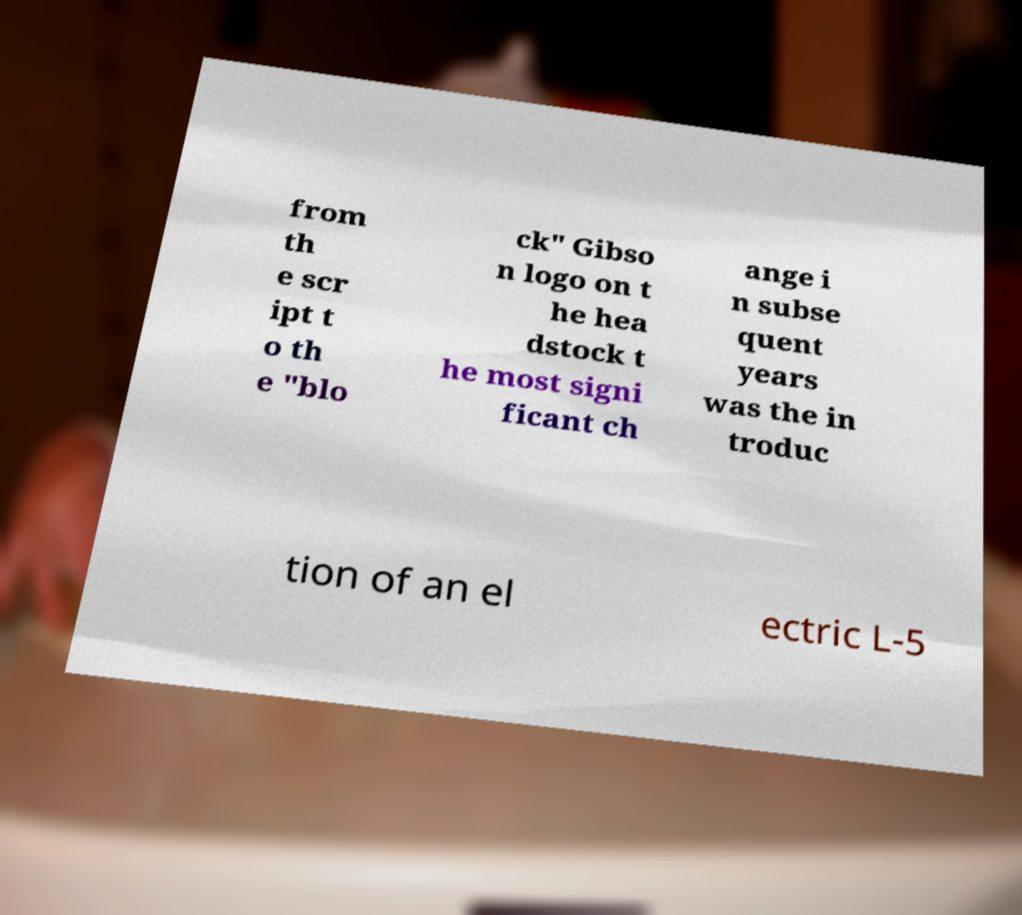Can you read and provide the text displayed in the image?This photo seems to have some interesting text. Can you extract and type it out for me? from th e scr ipt t o th e "blo ck" Gibso n logo on t he hea dstock t he most signi ficant ch ange i n subse quent years was the in troduc tion of an el ectric L-5 